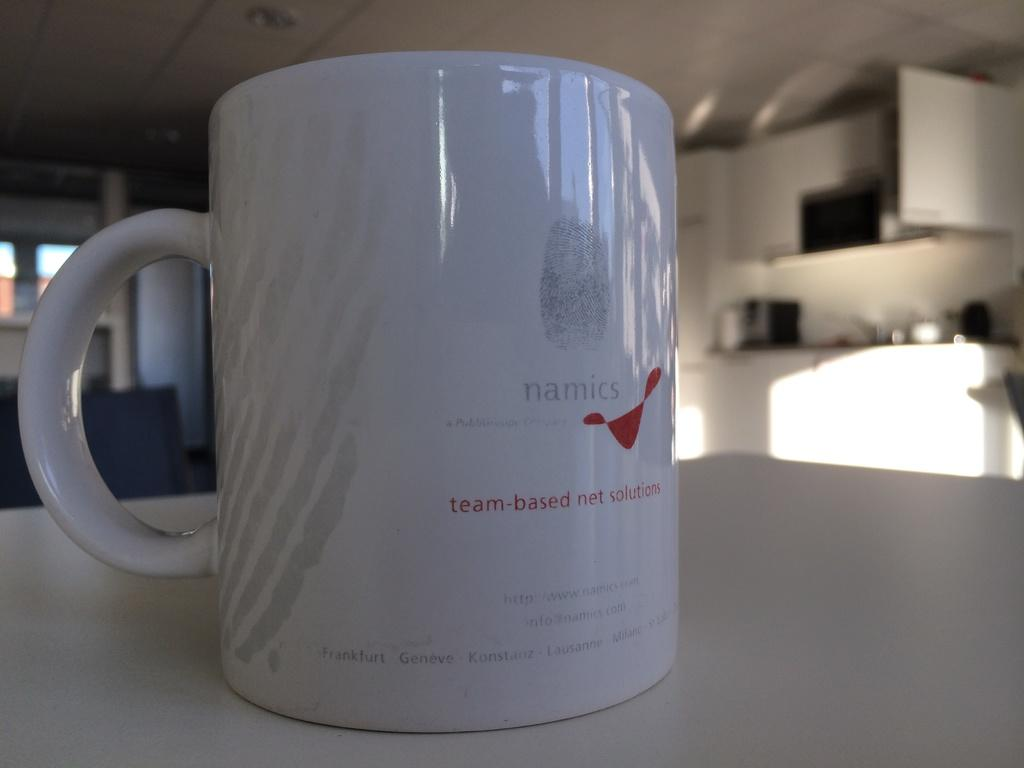<image>
Create a compact narrative representing the image presented. A white mug with a thumbprint and the company name namics printed on it. 